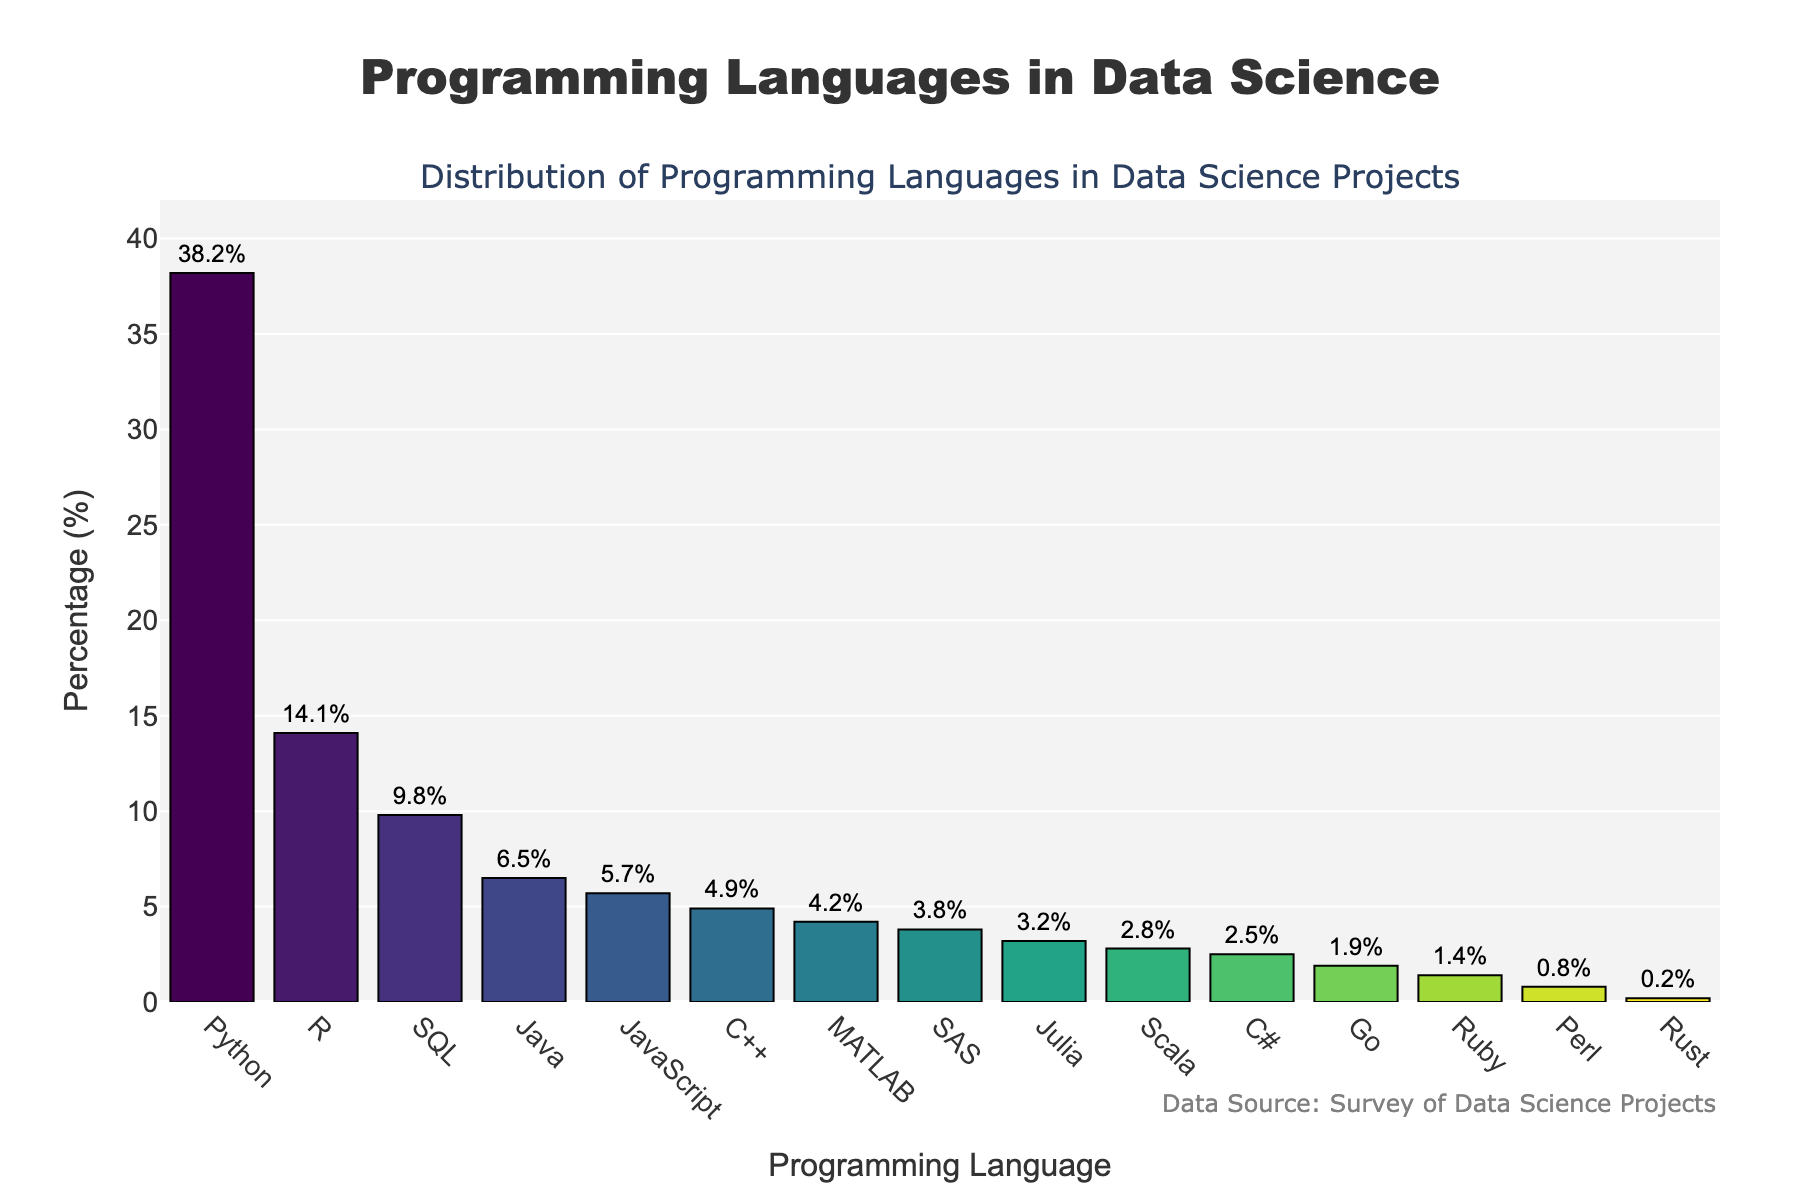Which programming language has the highest usage in data science projects? To determine which language has the highest usage, look at the bar with the greatest height. Python has the highest bar in the figure, indicating the highest usage.
Answer: Python What is the total percentage of usage for Python, R, and SQL combined? Add the percentages for Python (38.2), R (14.1), and SQL (9.8). The calculation is 38.2 + 14.1 + 9.8 = 62.1.
Answer: 62.1% Which programming language is used less frequently, MATLAB or SAS? Compare the heights of the bars for MATLAB and SAS. MATLAB has a higher bar at 4.2% compared to SAS at 3.8%, indicating SAS is used less frequently.
Answer: SAS What is the percentage difference between the usages of Java and JavaScript? Subtract the percentage of JavaScript (5.7) from Java (6.5): 6.5 - 5.7 = 0.8.
Answer: 0.8% How many programming languages have a usage percentage below 3%? Identify bars that are below the 3% mark. Julia (3.2) is the last above the threshold, so languages below are Scala (2.8), C# (2.5), Go (1.9), Ruby (1.4), Perl (0.8), and Rust (0.2), totaling 6 languages.
Answer: 6 Does R have more or less usage compared to SQL, and by how much? Compare the percentages of R (14.1) and SQL (9.8). R has more usage. Calculate the difference: 14.1 - 9.8 = 4.3.
Answer: More, by 4.3% Which programming language usage is closest to 5%? Identify the bars around 5%. JavaScript has the closest percentage at 5.7%.
Answer: JavaScript Are there any programming languages with exactly 3% usage? Check the bars to see if any have a height corresponding to 3%. None of the bars match exactly 3%; the closest are SAS (3.8) and Julia (3.2).
Answer: No What is the median usage percentage of all the programming languages? To find the median, list all percentages in ascending order and locate the middle value. The sorted list is: 0.2, 0.8, 1.4, 1.9, 2.5, 2.8, 3.2, 3.8, 4.2, 4.9, 5.7, 6.5, 9.8, 14.1, 38.2. The median is the 8th value, 3.8.
Answer: 3.8% What visual feature is used to display the usage percentages on the bars? The values are displayed as text labels outside the bars, showing the exact percentage for each language.
Answer: Text labels 